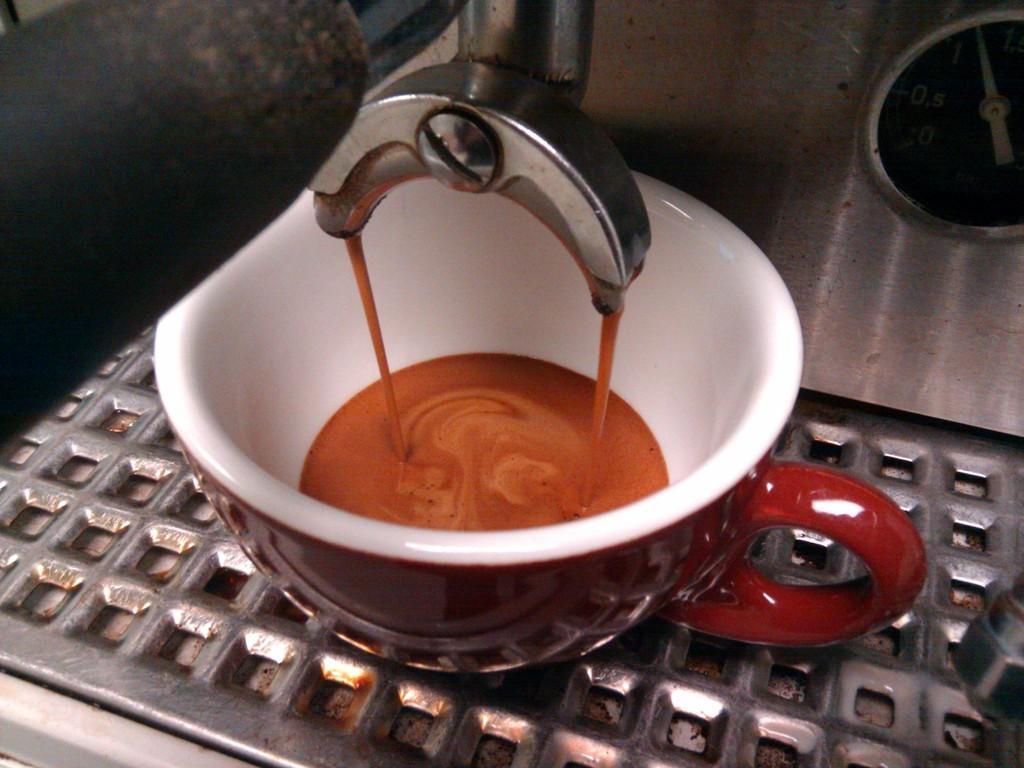Can you describe this image briefly? In this image I can see the machine and the cup with drink. I can see the cup is in maroon and white color and the drink is in brown color. It is on the steel surface. 